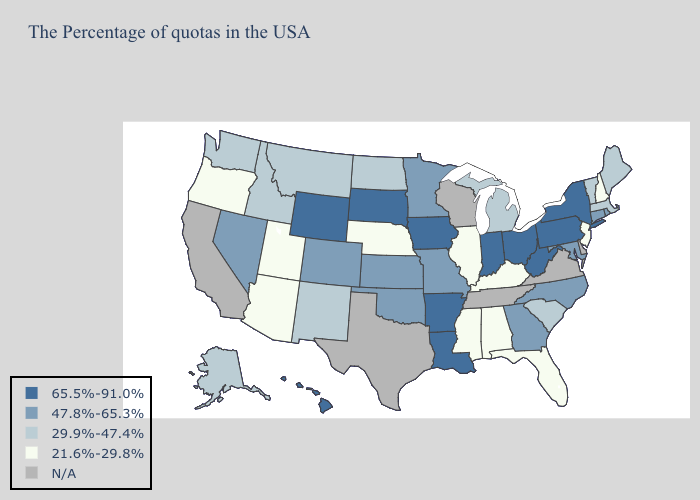Does Kentucky have the highest value in the USA?
Short answer required. No. What is the lowest value in states that border Massachusetts?
Answer briefly. 21.6%-29.8%. Does Alabama have the highest value in the USA?
Short answer required. No. Does New York have the highest value in the USA?
Concise answer only. Yes. Does the map have missing data?
Write a very short answer. Yes. Among the states that border Colorado , does Wyoming have the lowest value?
Be succinct. No. Which states have the lowest value in the USA?
Write a very short answer. New Hampshire, New Jersey, Florida, Kentucky, Alabama, Illinois, Mississippi, Nebraska, Utah, Arizona, Oregon. What is the highest value in the Northeast ?
Short answer required. 65.5%-91.0%. What is the highest value in the USA?
Quick response, please. 65.5%-91.0%. Which states have the lowest value in the USA?
Concise answer only. New Hampshire, New Jersey, Florida, Kentucky, Alabama, Illinois, Mississippi, Nebraska, Utah, Arizona, Oregon. Name the states that have a value in the range 65.5%-91.0%?
Short answer required. New York, Pennsylvania, West Virginia, Ohio, Indiana, Louisiana, Arkansas, Iowa, South Dakota, Wyoming, Hawaii. What is the value of Georgia?
Write a very short answer. 47.8%-65.3%. What is the lowest value in the Northeast?
Quick response, please. 21.6%-29.8%. Name the states that have a value in the range 29.9%-47.4%?
Quick response, please. Maine, Massachusetts, Vermont, South Carolina, Michigan, North Dakota, New Mexico, Montana, Idaho, Washington, Alaska. 